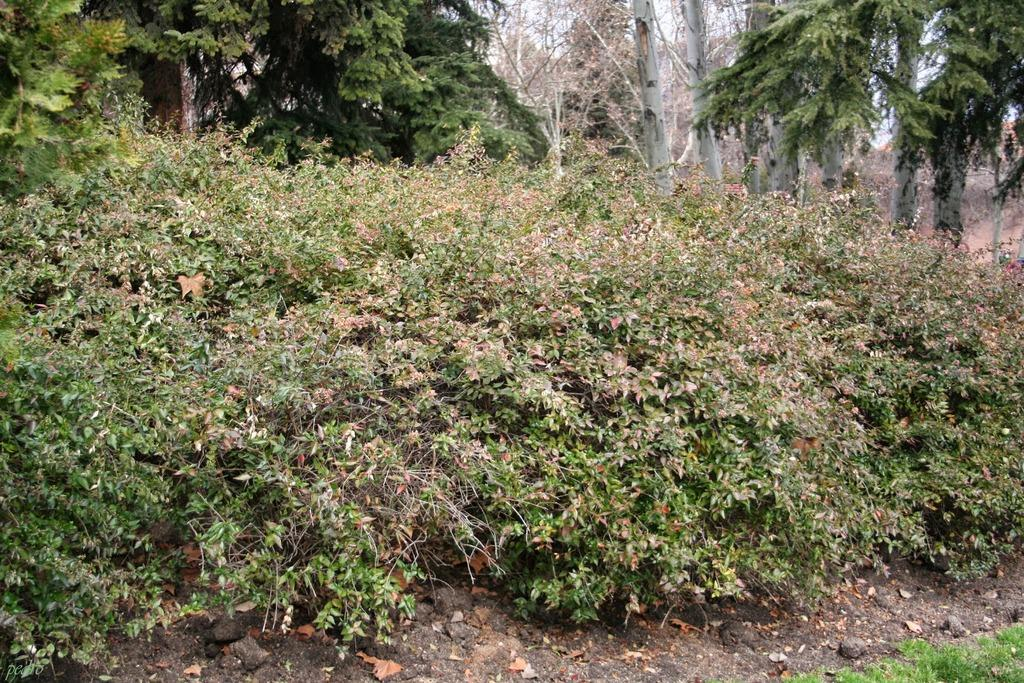What type of vegetation can be seen in the image? There are plants and trees in the image. What is the base material visible in the image? Soil is visible at the bottom of the image. What type of ground cover is present at the bottom of the image? Grass is present at the bottom of the image. What type of insect can be seen interacting with the society in the image? There is no insect or society present in the image; it features plants, trees, soil, and grass. 